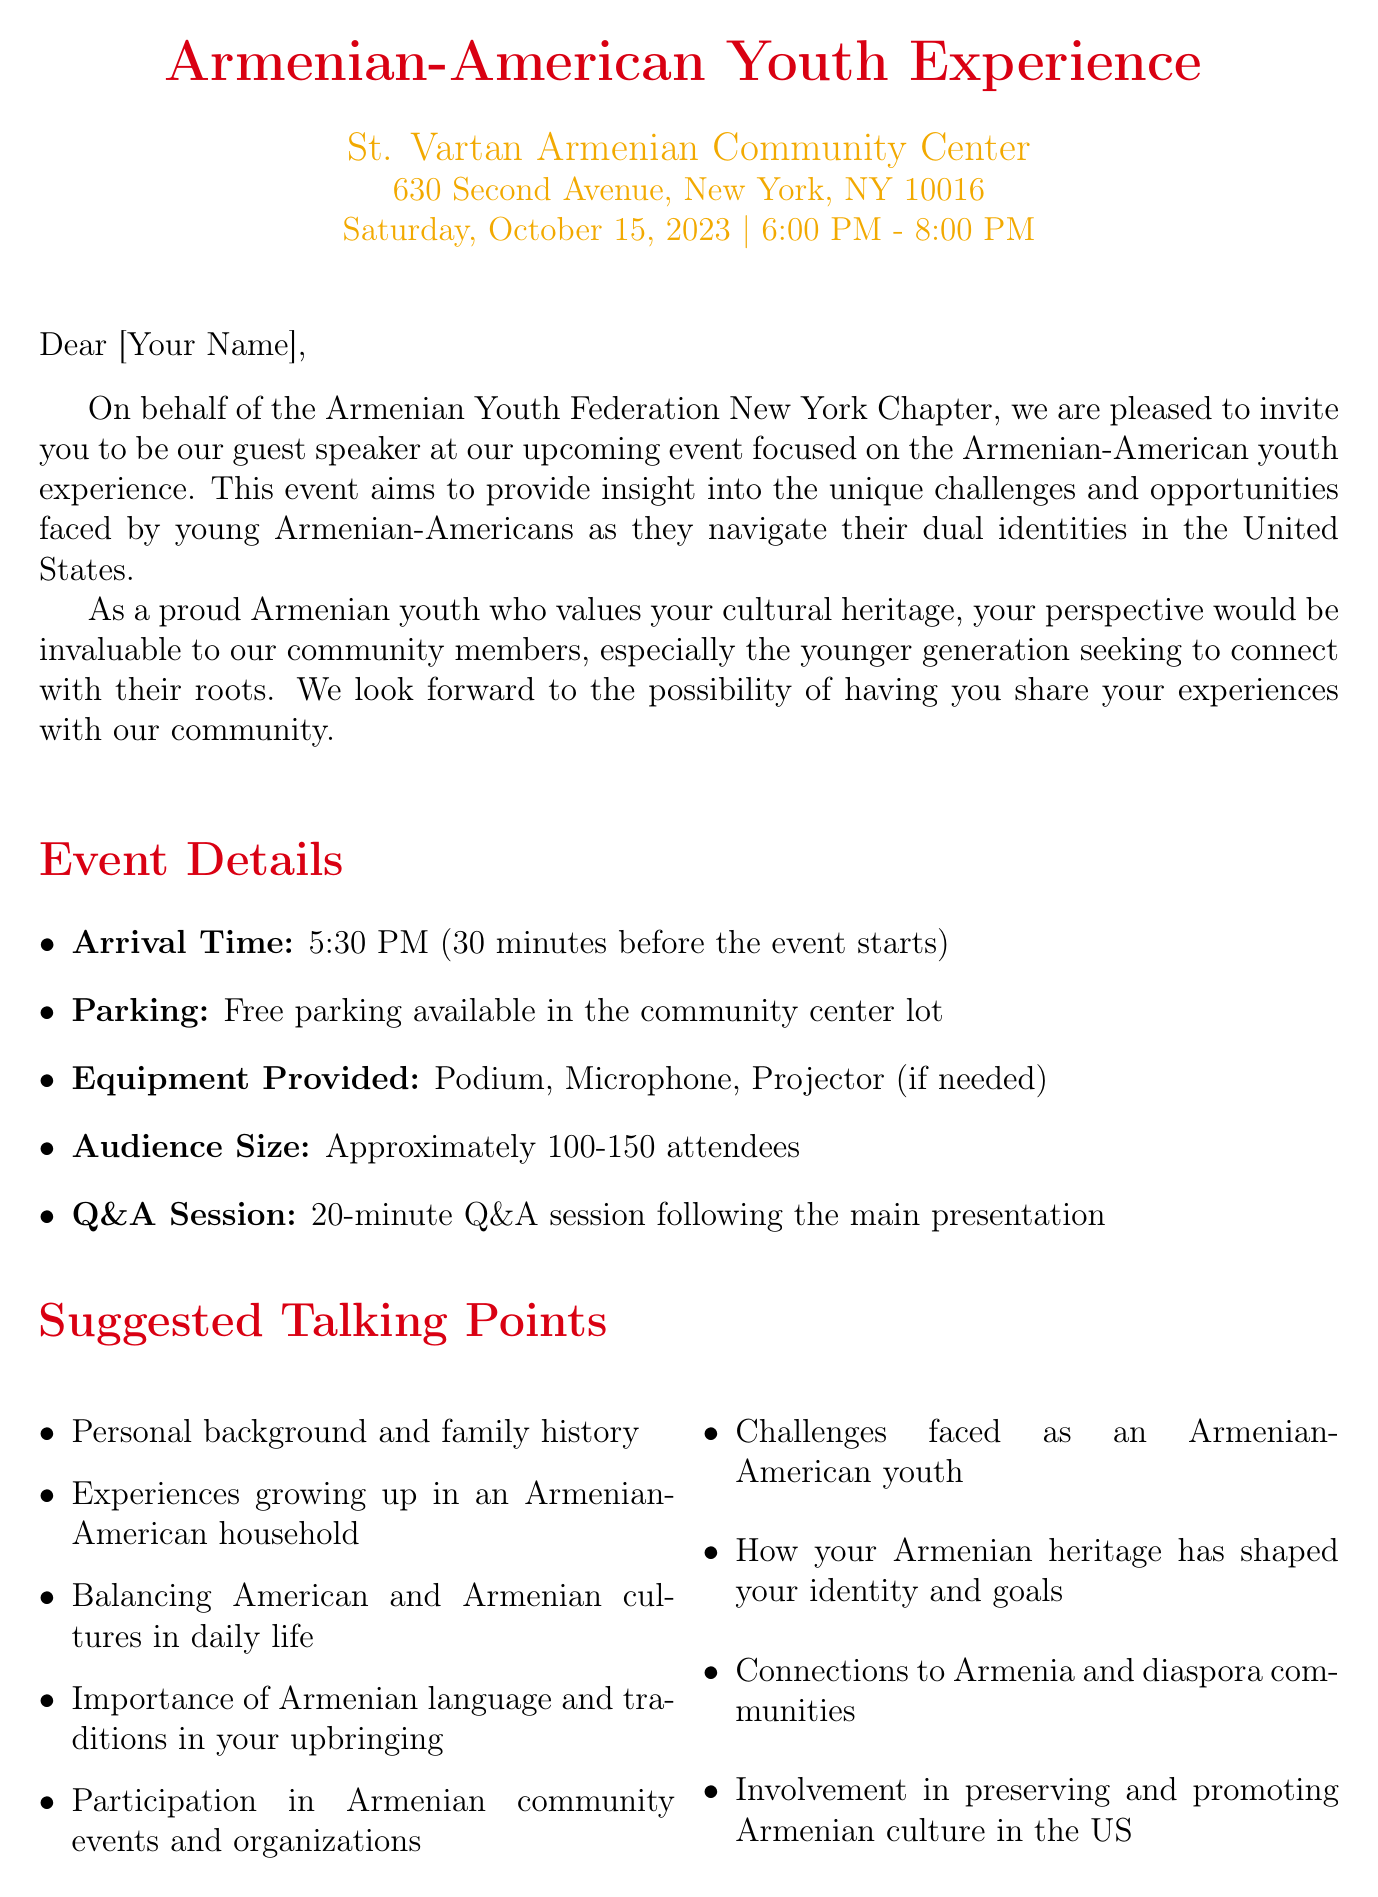What is the name of the event? The name of the event is specified in the document as "Armenian-American Youth Experience."
Answer: Armenian-American Youth Experience When is the event scheduled to take place? The date of the event is mentioned in the document as October 15, 2023.
Answer: October 15, 2023 What time does the event start? The starting time of the event is listed as 6:00 PM in the document.
Answer: 6:00 PM How long is the Q&A session? The document states that the Q&A session will last for 20 minutes.
Answer: 20 minutes How many attendees are expected? The document indicates that the audience size will be approximately 100-150 attendees.
Answer: Approximately 100-150 attendees What is the arrival time for the speaker? The arrival time for the speaker is specified in the document as 5:30 PM.
Answer: 5:30 PM Who is the organizer of the event? The event is organized by the Armenian Youth Federation (AYF) New York Chapter, as mentioned in the document.
Answer: Armenian Youth Federation (AYF) New York Chapter What type of refreshments will be served post-event? The document mentions that light refreshments and traditional Armenian pastries will be served.
Answer: Light refreshments and traditional Armenian pastries What is the purpose of the event? The purpose of the event is to provide insight into the challenges and opportunities faced by young Armenian-Americans.
Answer: Insight into the challenges and opportunities faced by young Armenian-Americans Which cultural traditions are suggested to incorporate? The document lists Armenian dance (Kochari) and traditional cuisine (Dolma, Khorovats) as suggested cultural traditions.
Answer: Armenian dance (Kochari), Traditional cuisine (Dolma, Khorovats) 